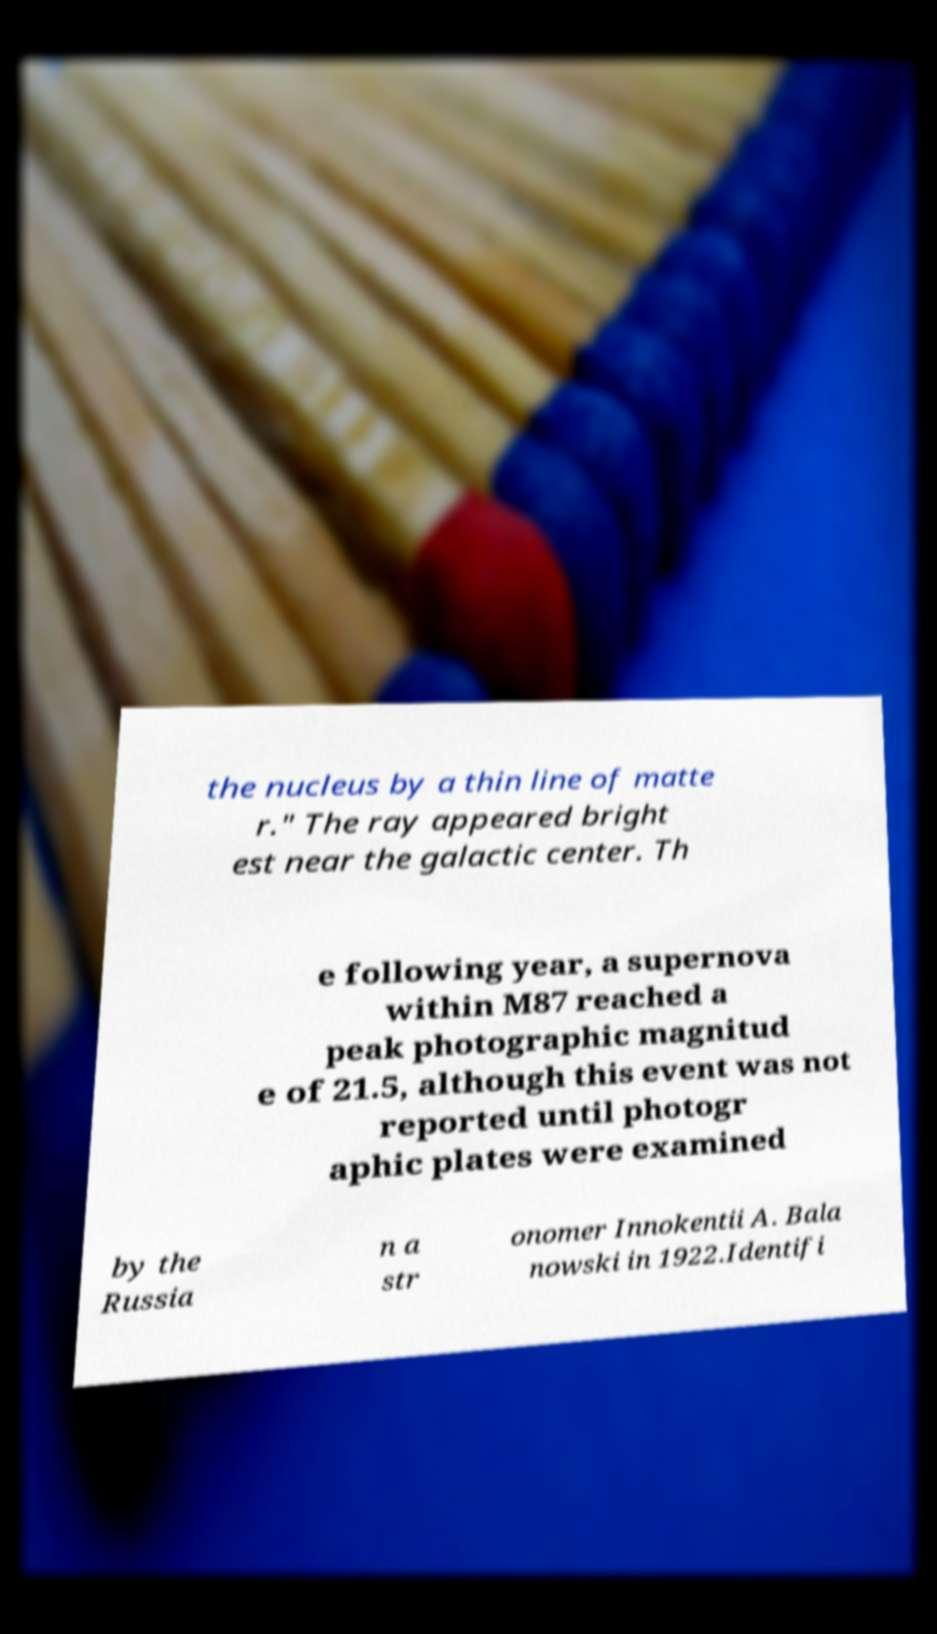Can you accurately transcribe the text from the provided image for me? the nucleus by a thin line of matte r." The ray appeared bright est near the galactic center. Th e following year, a supernova within M87 reached a peak photographic magnitud e of 21.5, although this event was not reported until photogr aphic plates were examined by the Russia n a str onomer Innokentii A. Bala nowski in 1922.Identifi 